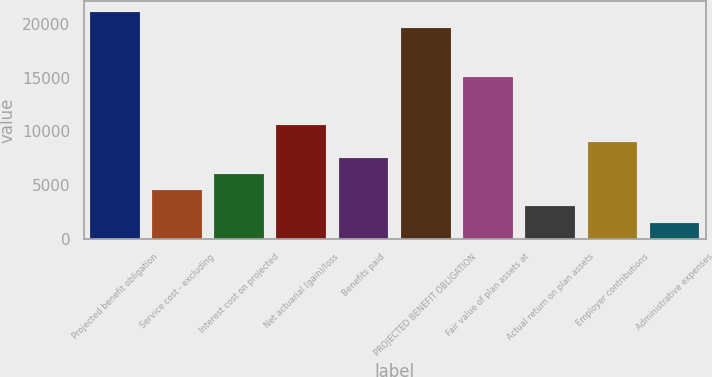Convert chart. <chart><loc_0><loc_0><loc_500><loc_500><bar_chart><fcel>Projected benefit obligation<fcel>Service cost - excluding<fcel>Interest cost on projected<fcel>Net actuarial (gain)/loss<fcel>Benefits paid<fcel>PROJECTED BENEFIT OBLIGATION<fcel>Fair value of plan assets at<fcel>Actual return on plan assets<fcel>Employer contributions<fcel>Administrative expenses<nl><fcel>21107<fcel>4535.5<fcel>6042<fcel>10561.5<fcel>7548.5<fcel>19600.5<fcel>15081<fcel>3029<fcel>9055<fcel>1522.5<nl></chart> 